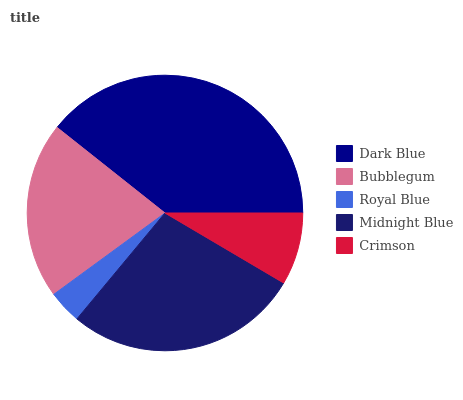Is Royal Blue the minimum?
Answer yes or no. Yes. Is Dark Blue the maximum?
Answer yes or no. Yes. Is Bubblegum the minimum?
Answer yes or no. No. Is Bubblegum the maximum?
Answer yes or no. No. Is Dark Blue greater than Bubblegum?
Answer yes or no. Yes. Is Bubblegum less than Dark Blue?
Answer yes or no. Yes. Is Bubblegum greater than Dark Blue?
Answer yes or no. No. Is Dark Blue less than Bubblegum?
Answer yes or no. No. Is Bubblegum the high median?
Answer yes or no. Yes. Is Bubblegum the low median?
Answer yes or no. Yes. Is Crimson the high median?
Answer yes or no. No. Is Dark Blue the low median?
Answer yes or no. No. 